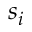Convert formula to latex. <formula><loc_0><loc_0><loc_500><loc_500>s _ { i }</formula> 